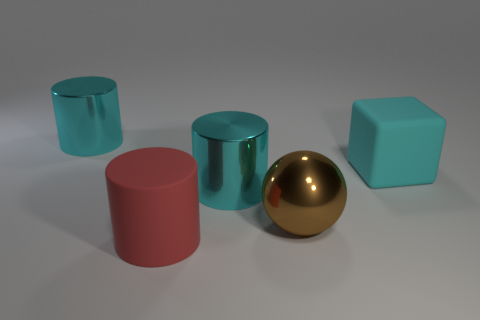Subtract all large cyan shiny cylinders. How many cylinders are left? 1 Add 4 tiny brown cylinders. How many objects exist? 9 Subtract all cubes. How many objects are left? 4 Subtract 0 purple balls. How many objects are left? 5 Subtract all rubber cylinders. Subtract all tiny brown rubber cylinders. How many objects are left? 4 Add 4 red objects. How many red objects are left? 5 Add 1 red matte objects. How many red matte objects exist? 2 